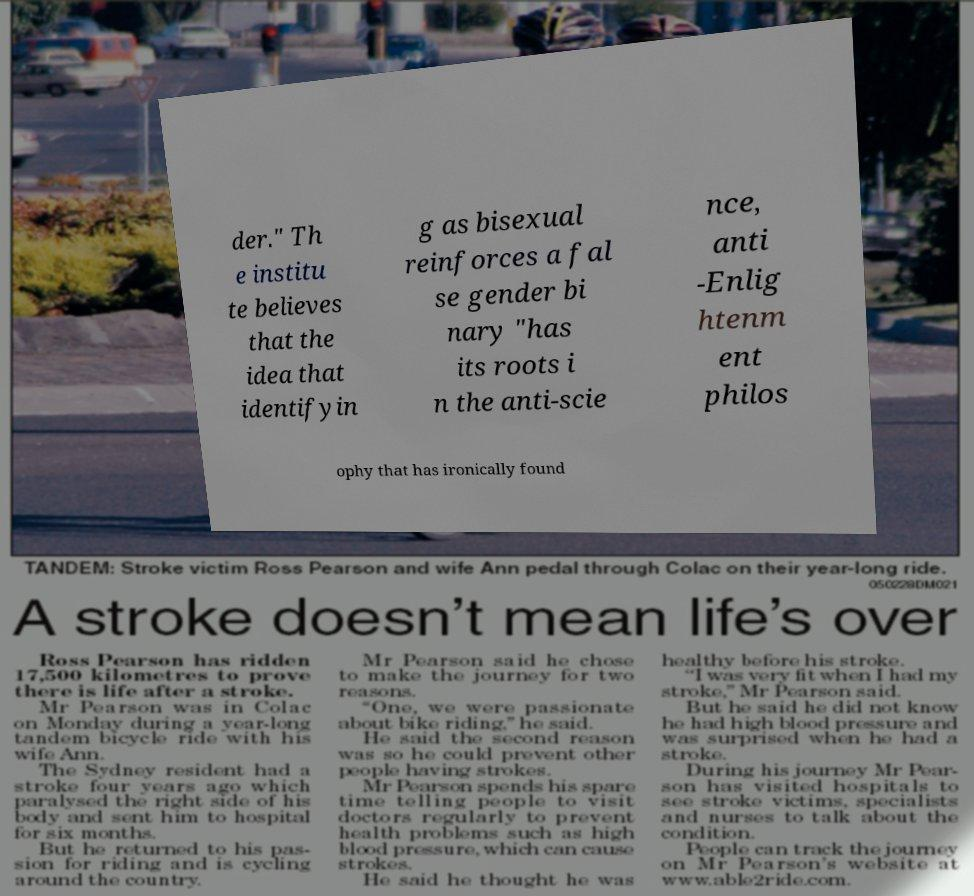Can you accurately transcribe the text from the provided image for me? der." Th e institu te believes that the idea that identifyin g as bisexual reinforces a fal se gender bi nary "has its roots i n the anti-scie nce, anti -Enlig htenm ent philos ophy that has ironically found 